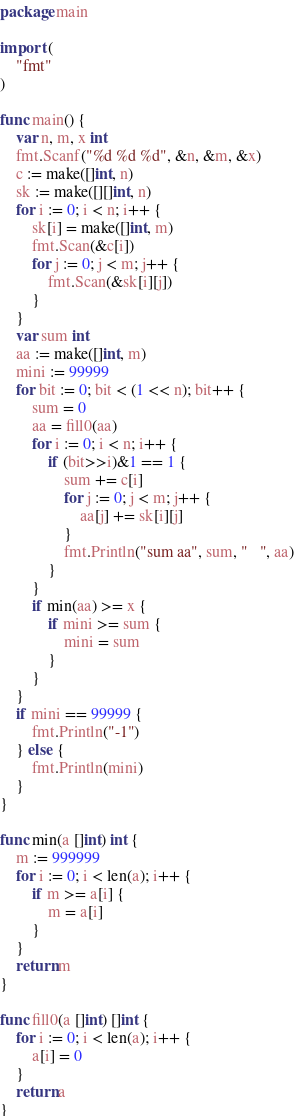<code> <loc_0><loc_0><loc_500><loc_500><_Go_>package main

import (
	"fmt"
)

func main() {
	var n, m, x int
	fmt.Scanf("%d %d %d", &n, &m, &x)
	c := make([]int, n)
	sk := make([][]int, n)
	for i := 0; i < n; i++ {
		sk[i] = make([]int, m)
		fmt.Scan(&c[i])
		for j := 0; j < m; j++ {
			fmt.Scan(&sk[i][j])
		}
	}
	var sum int
	aa := make([]int, m)
	mini := 99999
	for bit := 0; bit < (1 << n); bit++ {
		sum = 0
		aa = fill0(aa)
		for i := 0; i < n; i++ {
			if (bit>>i)&1 == 1 {
				sum += c[i]
				for j := 0; j < m; j++ {
					aa[j] += sk[i][j]
				}
				fmt.Println("sum aa", sum, "   ", aa)
			}
		}
		if min(aa) >= x {
			if mini >= sum {
				mini = sum
			}
		}
	}
	if mini == 99999 {
		fmt.Println("-1")
	} else {
		fmt.Println(mini)
	}
}

func min(a []int) int {
	m := 999999
	for i := 0; i < len(a); i++ {
		if m >= a[i] {
			m = a[i]
		}
	}
	return m
}

func fill0(a []int) []int {
	for i := 0; i < len(a); i++ {
		a[i] = 0
	}
	return a
}
</code> 